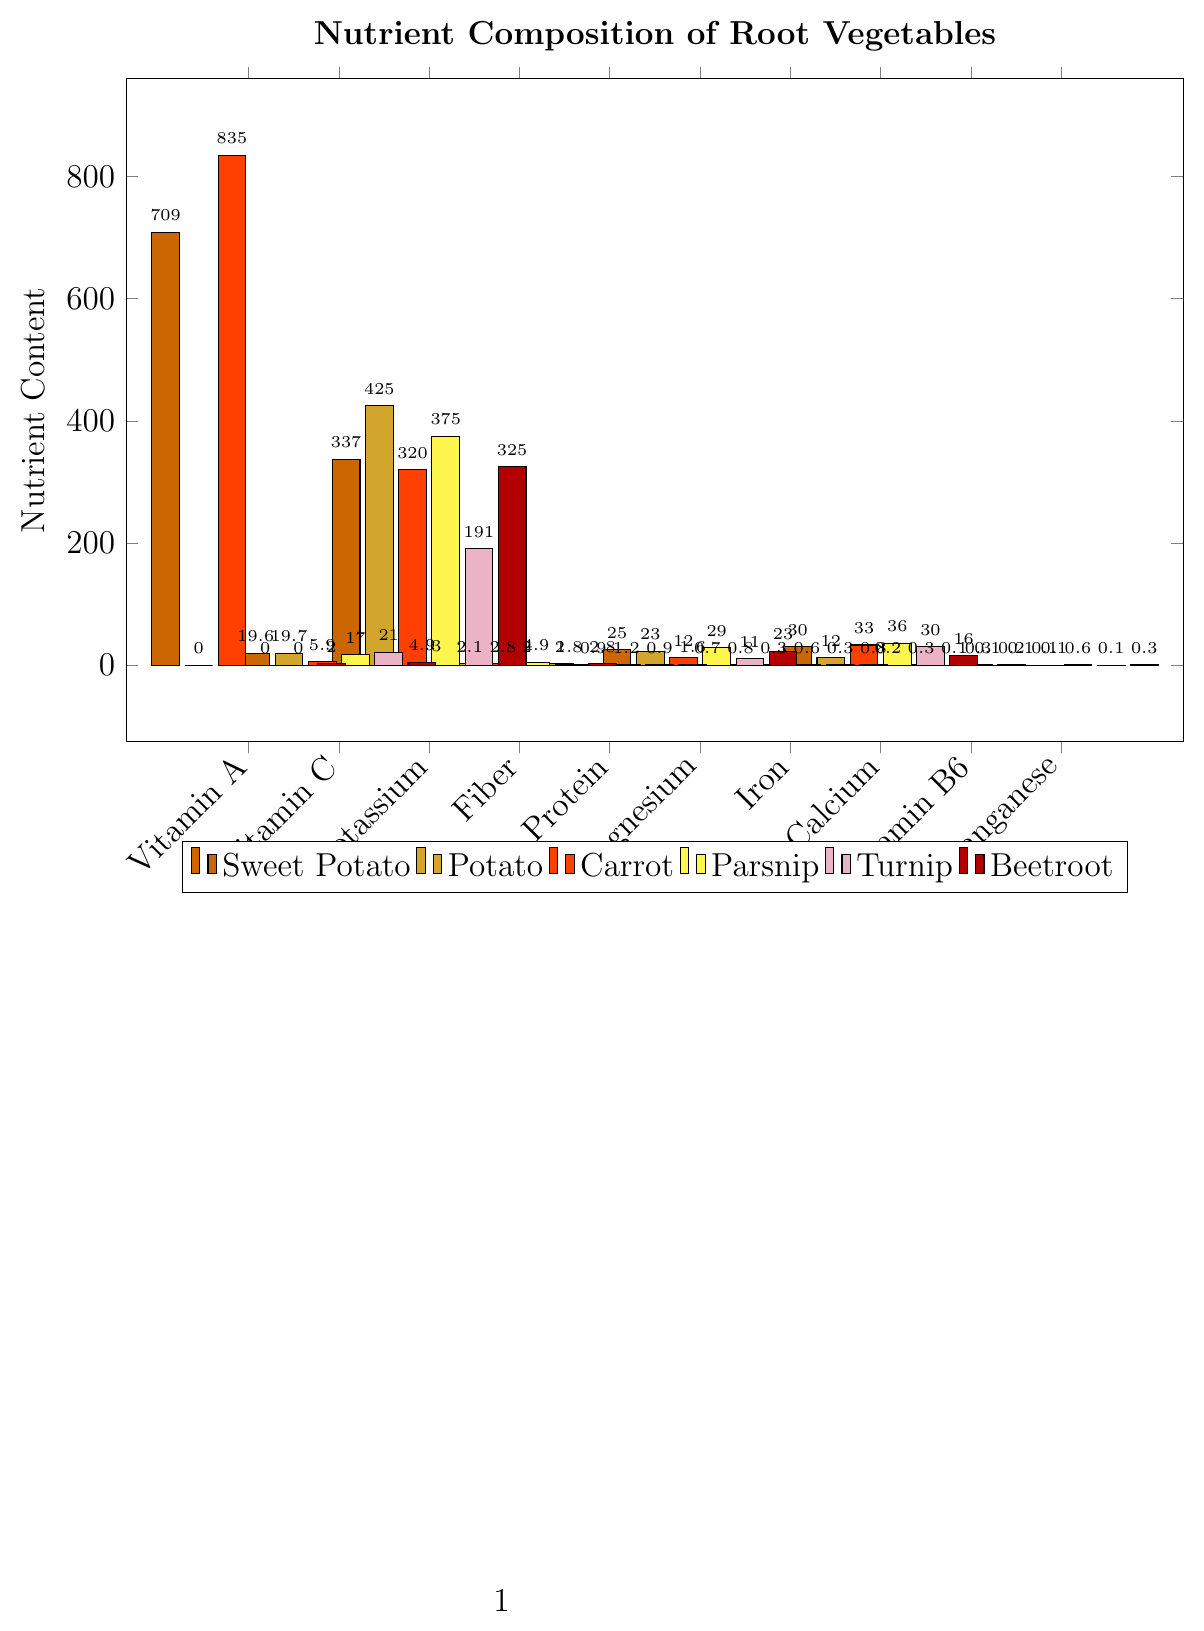What's the comparison of Vitamin A content in Sweet Potatoes and Carrots? Sweet Potatoes have 709 µg of Vitamin A, and Carrots have 835 µg. Comparing these, Carrots have a higher Vitamin A content.
Answer: Carrots have more Vitamin A Which root vegetable has the highest fiber content? By observing the height of the Fiber bars in the figure, Parsnip has the highest fiber content at 4.9g.
Answer: Parsnip What's the difference in Potassium content between Turnip and Potato? Turnip contains 191 mg of Potassium, and Potato contains 425 mg. The difference is 425 - 191 = 234 mg.
Answer: 234 mg Which nutrient in Sweet Potatoes has the highest value? The tallest bar for Sweet Potatoes corresponds to Vitamin A, with a value of 709 µg.
Answer: Vitamin A What's the average Calcium content across all root vegetables shown? The Calcium values are 30, 12, 33, 36, 30, 16 mg. Summing these: 30 + 12 + 33 + 36 + 30 + 16 = 157 mg. The average is 157 / 6 = 26.17 mg.
Answer: 26.17 mg Which vegetable has the least Vitamin C content and how much? By comparing the heights of the Vitamin C bars, Beetroot has the least Vitamin C content at 4.9 mg.
Answer: Beetroot, 4.9 mg How does the Iron content of Beetroot compare to Sweet Potato? Both Beetroot and Sweet Potato show an Iron content of 0.8 mg each, indicating they have equal Iron content.
Answer: Equal What's the total dietary Fiber content from Sweet Potatoes and Beetroots combined? Sweet Potatoes have 3g of Fiber, and Beetroots have 2.8g. Summing these: 3 + 2.8 = 5.8g.
Answer: 5.8g Which vegetable provides the most Magnesium and how much? By comparing the heights of the Magnesium bars, Parsnip has the highest Magnesium content at 29 mg.
Answer: Parsnip, 29 mg What's the visual difference in height between the Vitamin C bars for Sweet Potato and Carrot? The Vitamin C bar for Sweet Potato is at 19.6 mg, while for Carrot it is at 5.9 mg. The visual difference in bar height represents the difference in their Vitamin C content: 19.6 - 5.9 = 13.7 mg.
Answer: 13.7 mg 